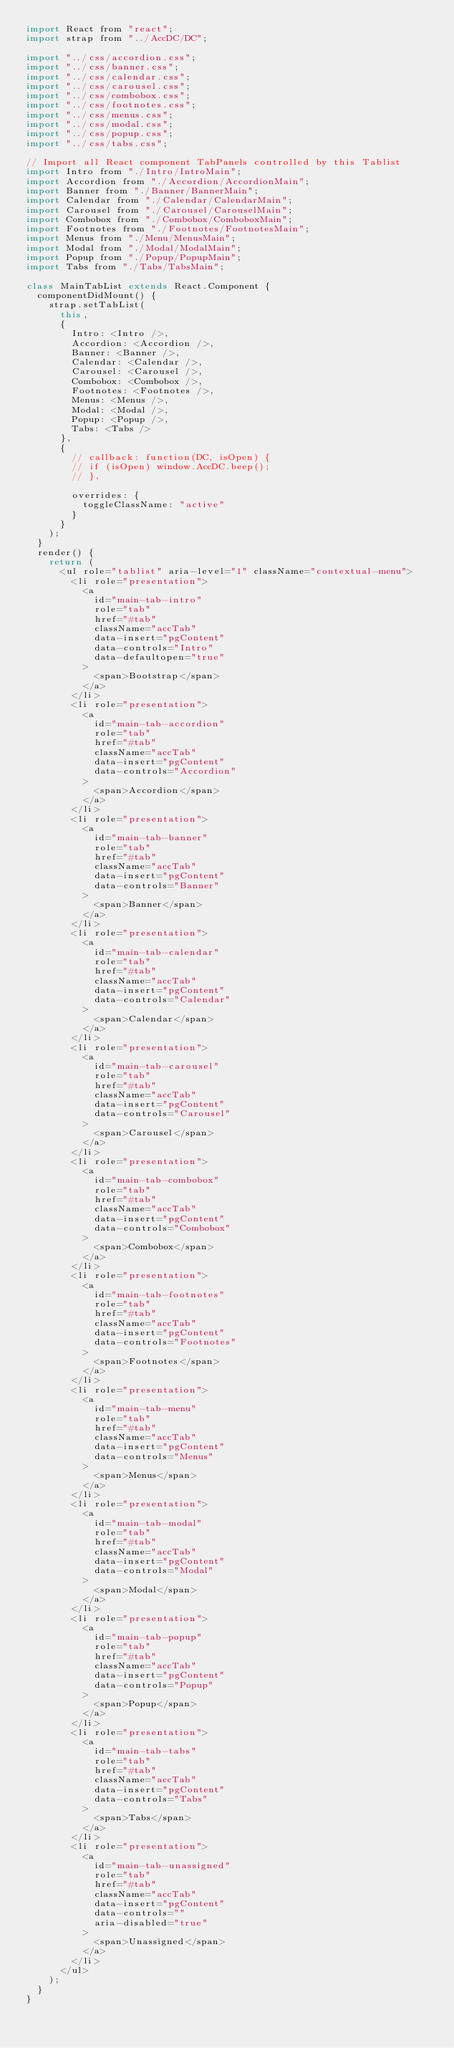Convert code to text. <code><loc_0><loc_0><loc_500><loc_500><_JavaScript_>import React from "react";
import strap from "../AccDC/DC";

import "../css/accordion.css";
import "../css/banner.css";
import "../css/calendar.css";
import "../css/carousel.css";
import "../css/combobox.css";
import "../css/footnotes.css";
import "../css/menus.css";
import "../css/modal.css";
import "../css/popup.css";
import "../css/tabs.css";

// Import all React component TabPanels controlled by this Tablist
import Intro from "./Intro/IntroMain";
import Accordion from "./Accordion/AccordionMain";
import Banner from "./Banner/BannerMain";
import Calendar from "./Calendar/CalendarMain";
import Carousel from "./Carousel/CarouselMain";
import Combobox from "./Combobox/ComboboxMain";
import Footnotes from "./Footnotes/FootnotesMain";
import Menus from "./Menu/MenusMain";
import Modal from "./Modal/ModalMain";
import Popup from "./Popup/PopupMain";
import Tabs from "./Tabs/TabsMain";

class MainTabList extends React.Component {
  componentDidMount() {
    strap.setTabList(
      this,
      {
        Intro: <Intro />,
        Accordion: <Accordion />,
        Banner: <Banner />,
        Calendar: <Calendar />,
        Carousel: <Carousel />,
        Combobox: <Combobox />,
        Footnotes: <Footnotes />,
        Menus: <Menus />,
        Modal: <Modal />,
        Popup: <Popup />,
        Tabs: <Tabs />
      },
      {
        // callback: function(DC, isOpen) {
        // if (isOpen) window.AccDC.beep();
        // },

        overrides: {
          toggleClassName: "active"
        }
      }
    );
  }
  render() {
    return (
      <ul role="tablist" aria-level="1" className="contextual-menu">
        <li role="presentation">
          <a
            id="main-tab-intro"
            role="tab"
            href="#tab"
            className="accTab"
            data-insert="pgContent"
            data-controls="Intro"
            data-defaultopen="true"
          >
            <span>Bootstrap</span>
          </a>
        </li>
        <li role="presentation">
          <a
            id="main-tab-accordion"
            role="tab"
            href="#tab"
            className="accTab"
            data-insert="pgContent"
            data-controls="Accordion"
          >
            <span>Accordion</span>
          </a>
        </li>
        <li role="presentation">
          <a
            id="main-tab-banner"
            role="tab"
            href="#tab"
            className="accTab"
            data-insert="pgContent"
            data-controls="Banner"
          >
            <span>Banner</span>
          </a>
        </li>
        <li role="presentation">
          <a
            id="main-tab-calendar"
            role="tab"
            href="#tab"
            className="accTab"
            data-insert="pgContent"
            data-controls="Calendar"
          >
            <span>Calendar</span>
          </a>
        </li>
        <li role="presentation">
          <a
            id="main-tab-carousel"
            role="tab"
            href="#tab"
            className="accTab"
            data-insert="pgContent"
            data-controls="Carousel"
          >
            <span>Carousel</span>
          </a>
        </li>
        <li role="presentation">
          <a
            id="main-tab-combobox"
            role="tab"
            href="#tab"
            className="accTab"
            data-insert="pgContent"
            data-controls="Combobox"
          >
            <span>Combobox</span>
          </a>
        </li>
        <li role="presentation">
          <a
            id="main-tab-footnotes"
            role="tab"
            href="#tab"
            className="accTab"
            data-insert="pgContent"
            data-controls="Footnotes"
          >
            <span>Footnotes</span>
          </a>
        </li>
        <li role="presentation">
          <a
            id="main-tab-menu"
            role="tab"
            href="#tab"
            className="accTab"
            data-insert="pgContent"
            data-controls="Menus"
          >
            <span>Menus</span>
          </a>
        </li>
        <li role="presentation">
          <a
            id="main-tab-modal"
            role="tab"
            href="#tab"
            className="accTab"
            data-insert="pgContent"
            data-controls="Modal"
          >
            <span>Modal</span>
          </a>
        </li>
        <li role="presentation">
          <a
            id="main-tab-popup"
            role="tab"
            href="#tab"
            className="accTab"
            data-insert="pgContent"
            data-controls="Popup"
          >
            <span>Popup</span>
          </a>
        </li>
        <li role="presentation">
          <a
            id="main-tab-tabs"
            role="tab"
            href="#tab"
            className="accTab"
            data-insert="pgContent"
            data-controls="Tabs"
          >
            <span>Tabs</span>
          </a>
        </li>
        <li role="presentation">
          <a
            id="main-tab-unassigned"
            role="tab"
            href="#tab"
            className="accTab"
            data-insert="pgContent"
            data-controls=""
            aria-disabled="true"
          >
            <span>Unassigned</span>
          </a>
        </li>
      </ul>
    );
  }
}
</code> 